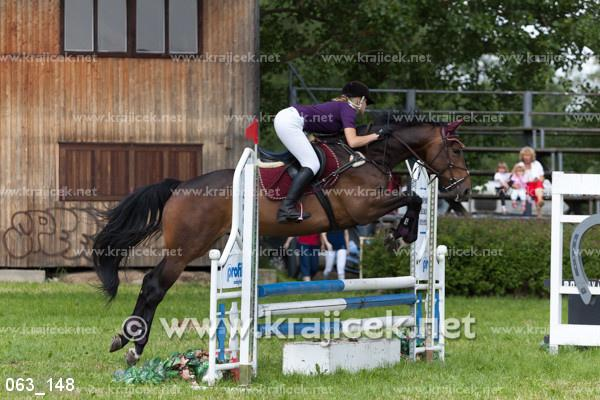What activity is the horse shown here taking part in? jumping 